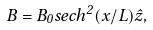Convert formula to latex. <formula><loc_0><loc_0><loc_500><loc_500>B = B _ { 0 } s e c h ^ { 2 } ( x / L ) \hat { z } ,</formula> 